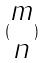<formula> <loc_0><loc_0><loc_500><loc_500>( \begin{matrix} m \\ n \end{matrix} )</formula> 